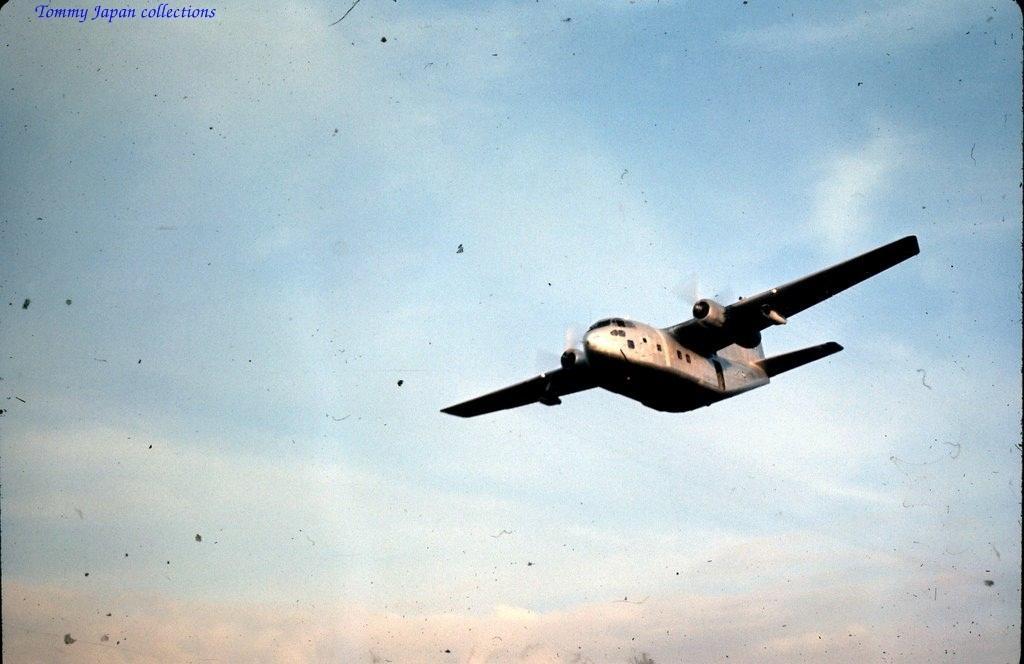Please provide a concise description of this image. In the image we can see a flying jet, in the sky. Here we can see the cloudy sky and there is a watermark at the left top. 